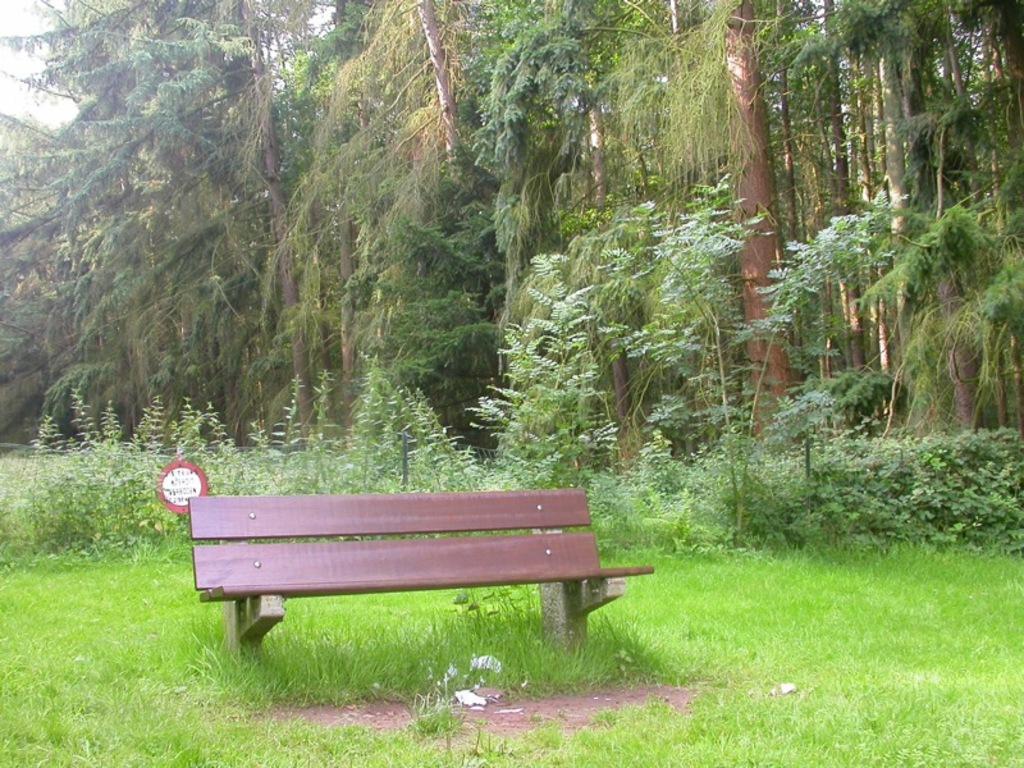Can you describe this image briefly? In this image I can see at the bottom there is grass. In the middle it looks like a bench chair. In the background there are trees. 